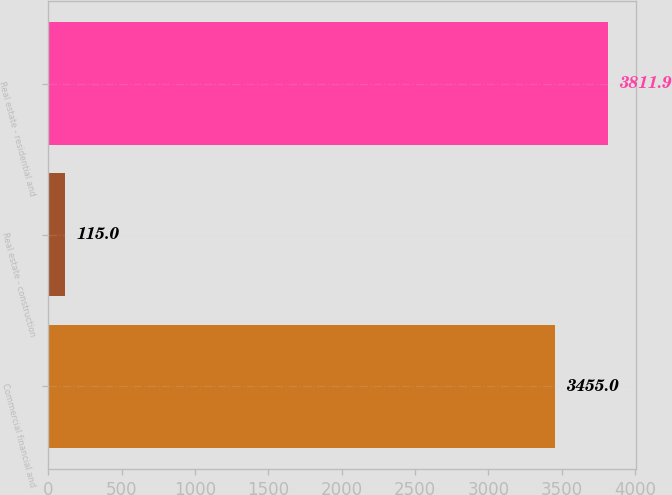Convert chart. <chart><loc_0><loc_0><loc_500><loc_500><bar_chart><fcel>Commercial financial and<fcel>Real estate - construction<fcel>Real estate - residential and<nl><fcel>3455<fcel>115<fcel>3811.9<nl></chart> 